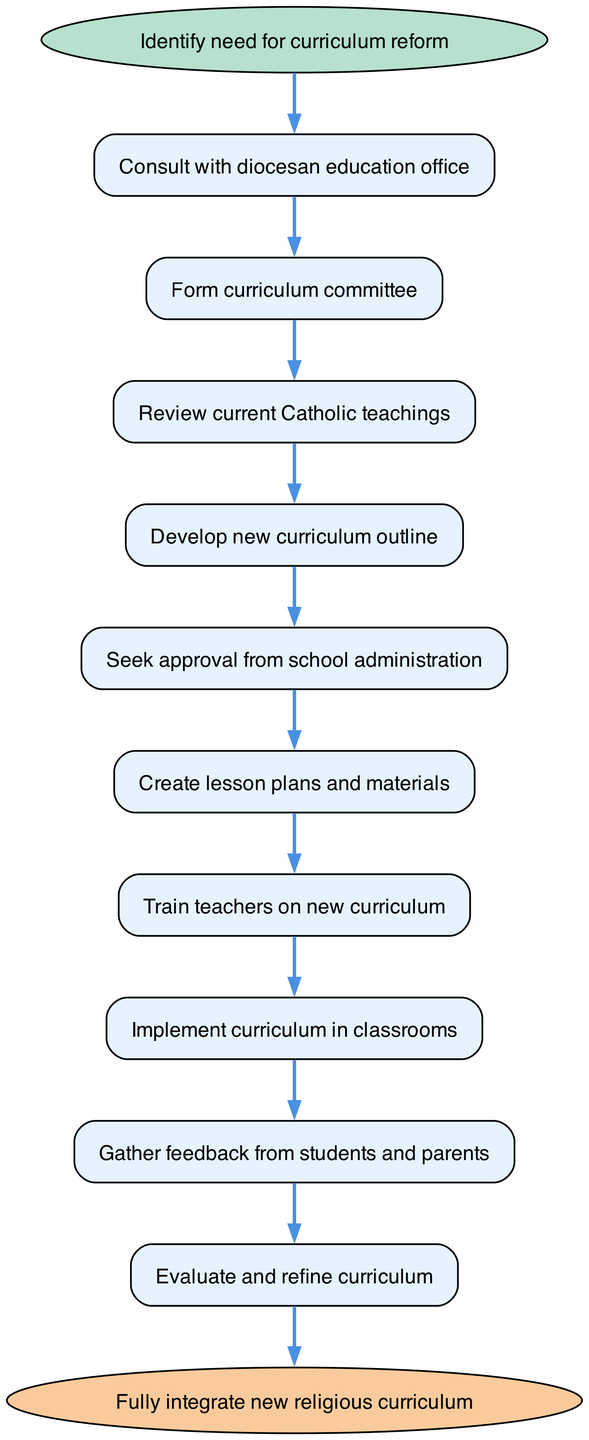What is the first step in the curriculum implementation process? The diagram shows that the first step is labeled "Identify need for curriculum reform", indicating that this is the starting point of the process.
Answer: Identify need for curriculum reform How many total steps are there in the process? By counting each element in the diagram, we find that there are 11 total nodes that represent the steps involved from start to end.
Answer: 11 What is the last step before the final integration of the new curriculum? Looking at the connections, the last step before reaching the end node is "Evaluate and refine curriculum", which is one step prior to the final implementation.
Answer: Evaluate and refine curriculum Which step involves consultation with the diocesan education office? The diagram shows that after identifying the need for reform, the next step is "Consult with diocesan education office", indicating that this is where consultation happens.
Answer: Consult with diocesan education office What precedes the creation of lesson plans and materials? The step immediately before "Create lesson plans and materials" in the flow is "Seek approval from school administration", establishing the order of the tasks.
Answer: Seek approval from school administration Which step focuses on training teachers? The diagram indicates that the step focused on teacher training directly follows the creation of lesson plans and is labeled "Train teachers on new curriculum".
Answer: Train teachers on new curriculum What follows after the implementation of the curriculum in classrooms? Reviewing the connections in the diagram, we see that the step following "Implement curriculum in classrooms" is "Gather feedback from students and parents".
Answer: Gather feedback from students and parents What might be a reason for needing to evaluate the curriculum after implementation? Analyzing the flow, the "Evaluate and refine curriculum" step comes after gathering feedback, suggesting that this evaluation is essential for making necessary adjustments based on input received.
Answer: Gather feedback from students and parents How is the curriculum development process initiated? The process is initiated by first identifying a need for curriculum reform, which is explicitly stated as the first step in the diagram.
Answer: Identify need for curriculum reform 